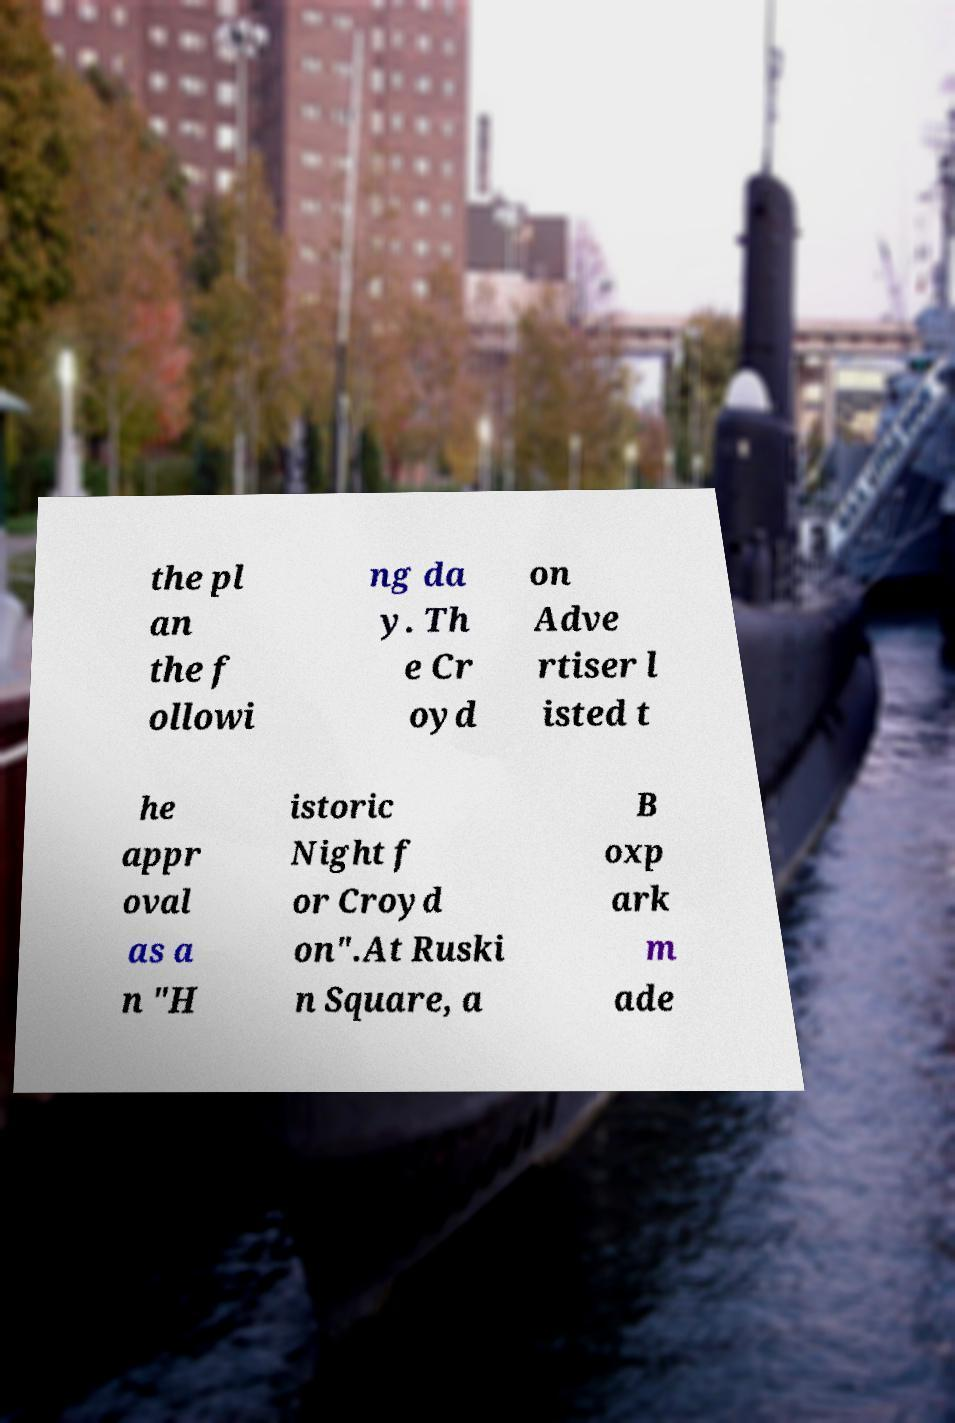Please read and relay the text visible in this image. What does it say? the pl an the f ollowi ng da y. Th e Cr oyd on Adve rtiser l isted t he appr oval as a n "H istoric Night f or Croyd on".At Ruski n Square, a B oxp ark m ade 